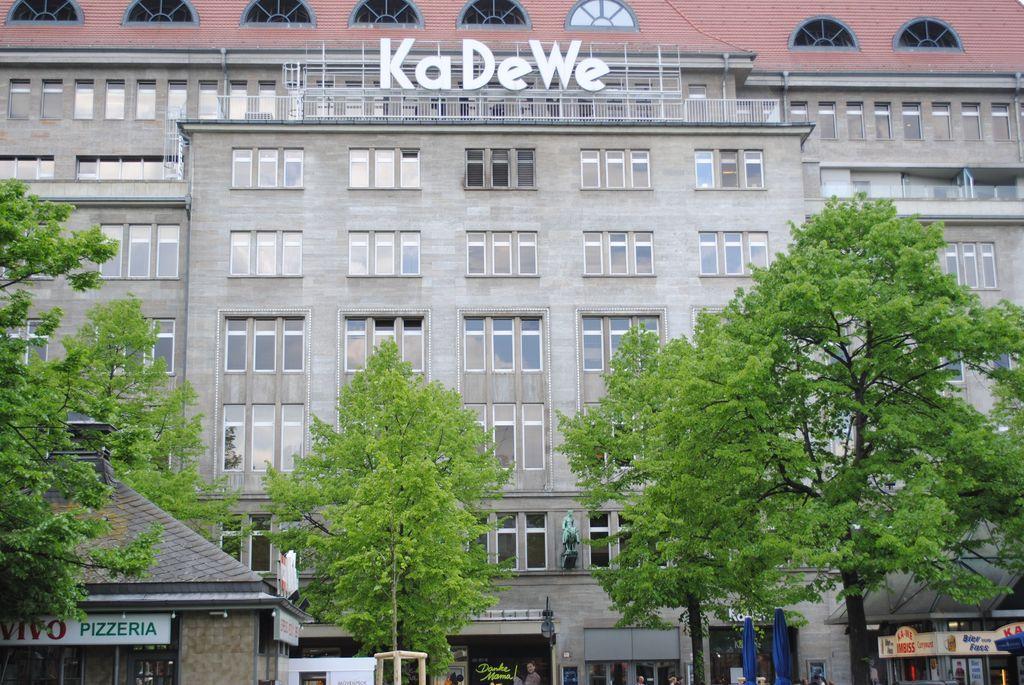Can you describe this image briefly? This picture is clicked outside. In the foreground we can see the text and some pictures on the boards and we can see some persons like things and we can see the trees, sculptures of some objects and we can see the building, text attached to the building and we can see the metal rods and many other items. 